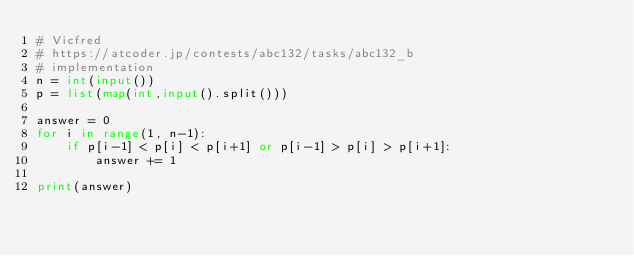Convert code to text. <code><loc_0><loc_0><loc_500><loc_500><_Python_># Vicfred
# https://atcoder.jp/contests/abc132/tasks/abc132_b
# implementation
n = int(input())
p = list(map(int,input().split()))

answer = 0
for i in range(1, n-1):
    if p[i-1] < p[i] < p[i+1] or p[i-1] > p[i] > p[i+1]:
        answer += 1

print(answer)

</code> 